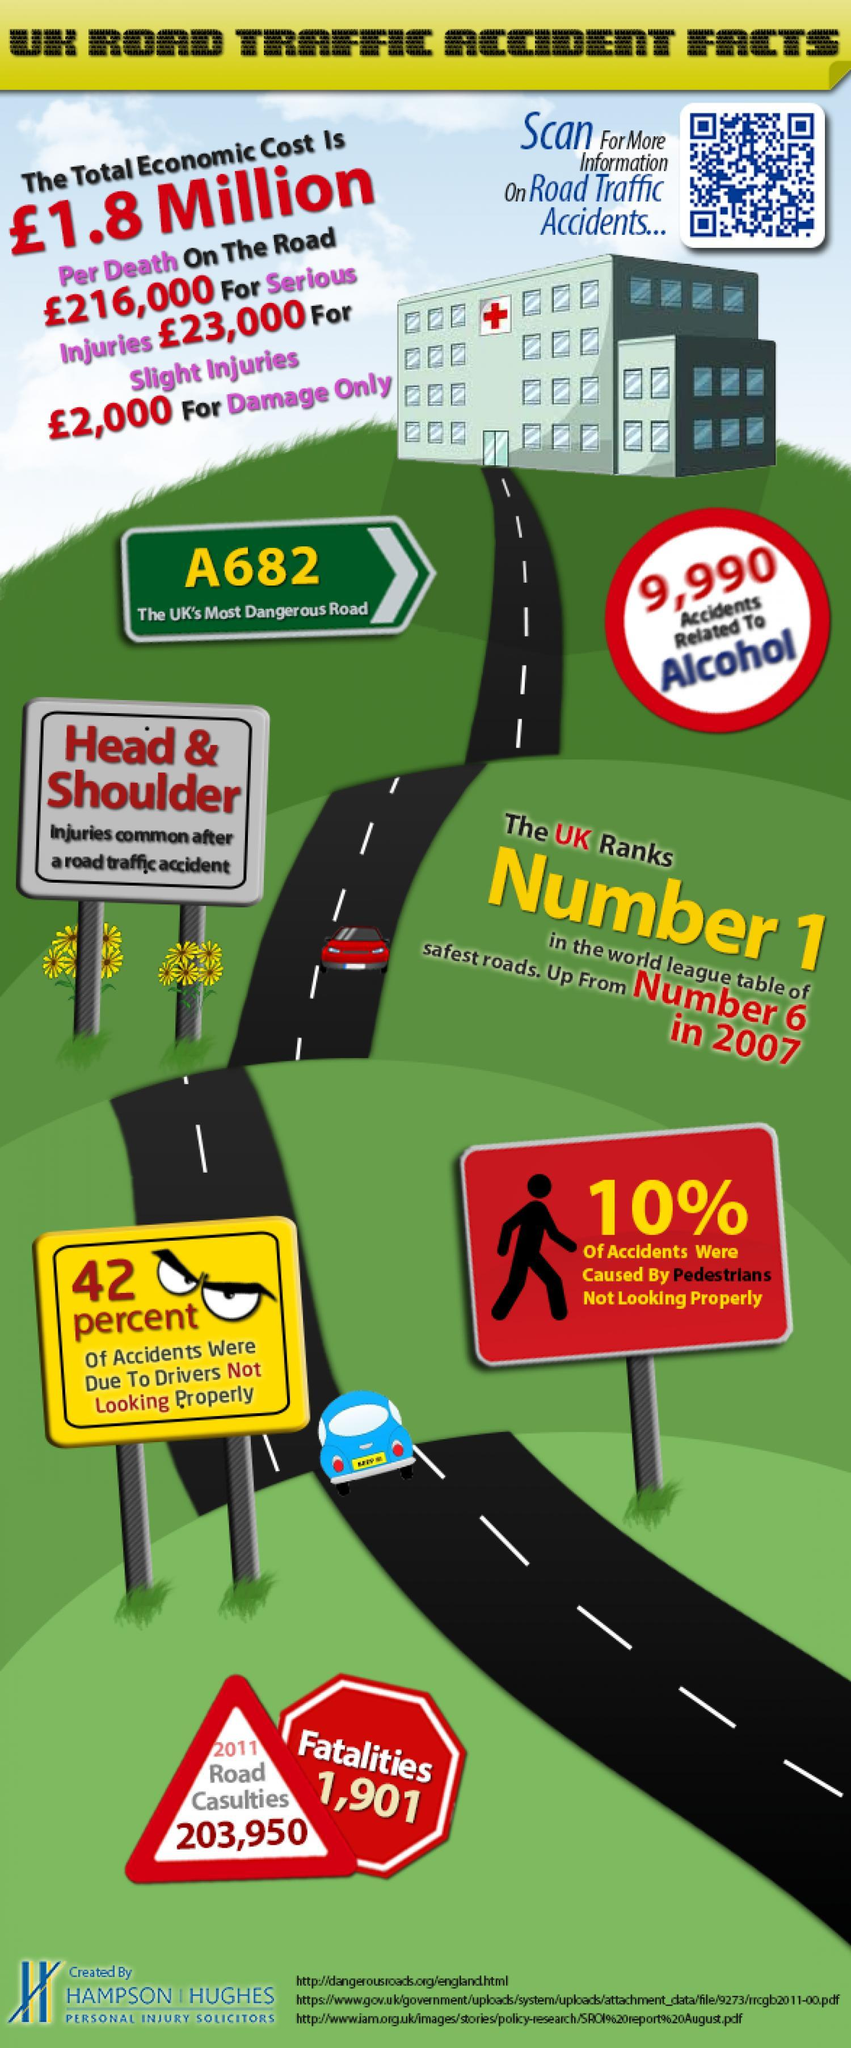How many casualities were reported in road accidents in UK in 2011?
Answer the question with a short phrase. 203,950 How many accidents in UK are caused due to alcohol? 9,990 How many fatalities were reported in road accidents in UK in 2011? 1,901 